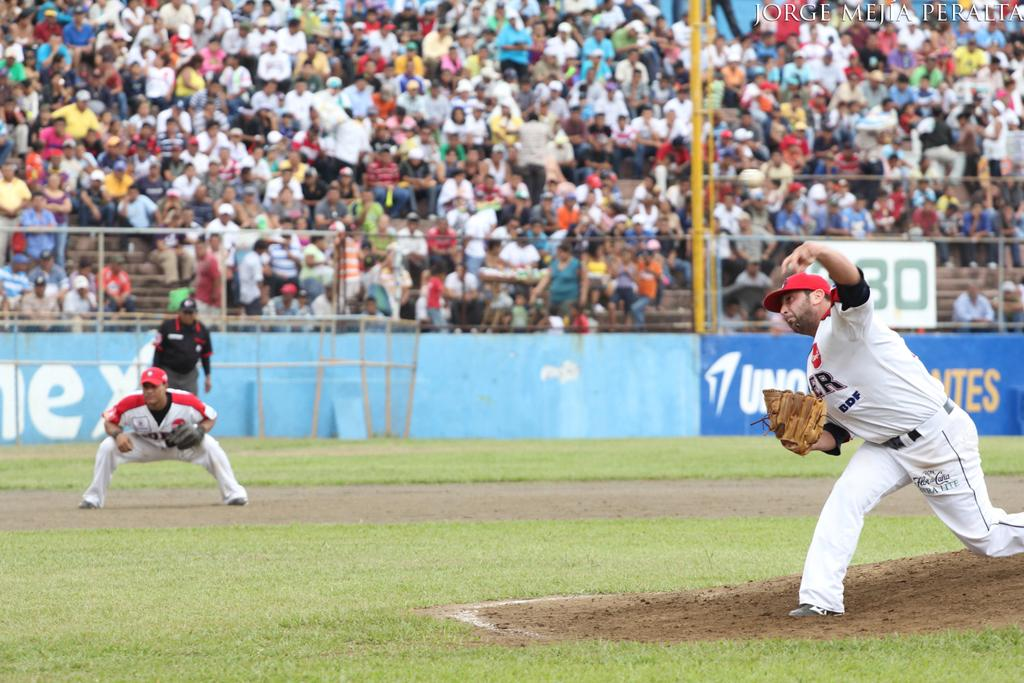<image>
Create a compact narrative representing the image presented. Ultra Lite reads the sponsor on the pants of the pitcher. 